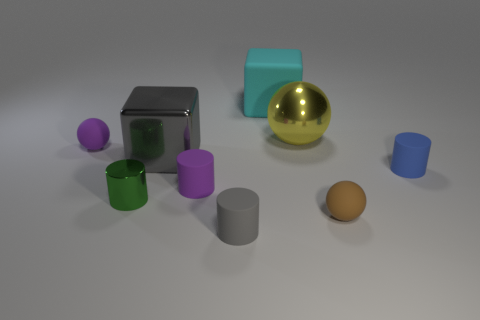Subtract all purple cylinders. Subtract all brown cubes. How many cylinders are left? 3 Add 1 green metal cylinders. How many objects exist? 10 Subtract all cylinders. How many objects are left? 5 Subtract 1 blue cylinders. How many objects are left? 8 Subtract all brown cylinders. Subtract all purple rubber cylinders. How many objects are left? 8 Add 5 cyan things. How many cyan things are left? 6 Add 3 balls. How many balls exist? 6 